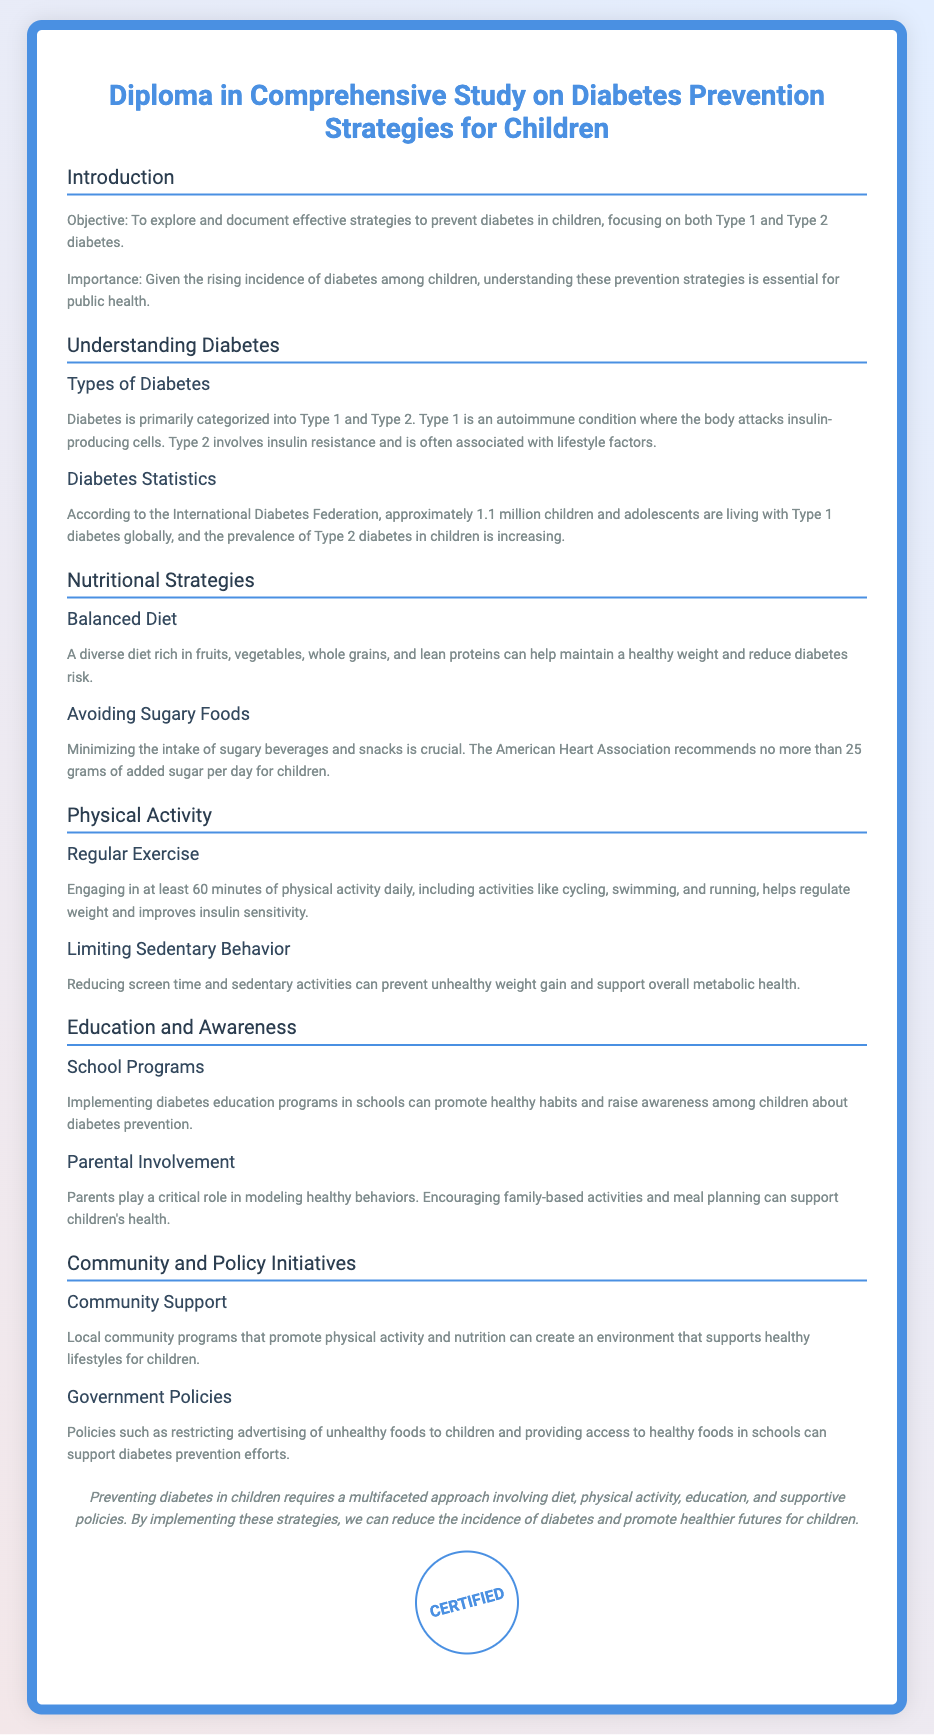What is the objective of the diploma? The objective outlined in the document is to explore and document effective strategies to prevent diabetes in children.
Answer: To explore and document effective strategies to prevent diabetes in children What are the two main types of diabetes mentioned? The document specifies Type 1 and Type 2 diabetes as the two main types.
Answer: Type 1 and Type 2 Approximately how many children globally live with Type 1 diabetes? The document states that approximately 1.1 million children and adolescents are living with Type 1 diabetes globally.
Answer: 1.1 million What is the recommended daily limit of added sugar for children according to the document? The American Heart Association recommends no more than 25 grams of added sugar per day for children as mentioned in the document.
Answer: 25 grams How many minutes of physical activity should children engage in daily? The document specifies that children should engage in at least 60 minutes of physical activity daily.
Answer: 60 minutes What role do parents play in children's diabetes prevention? The document states that parents play a critical role in modeling healthy behaviors.
Answer: Modeling healthy behaviors What is an example of a community initiative mentioned for diabetes prevention? The document mentions local community programs that promote physical activity and nutrition as an example of community initiatives.
Answer: Community programs Which organization is referenced in the document for dietary recommendations? The American Heart Association is referenced in the document for dietary recommendations regarding sugar intake.
Answer: American Heart Association What is emphasized as essential for effective diabetes prevention in children? The conclusion of the document emphasizes a multifaceted approach involving diet, physical activity, education, and supportive policies as essential.
Answer: A multifaceted approach 